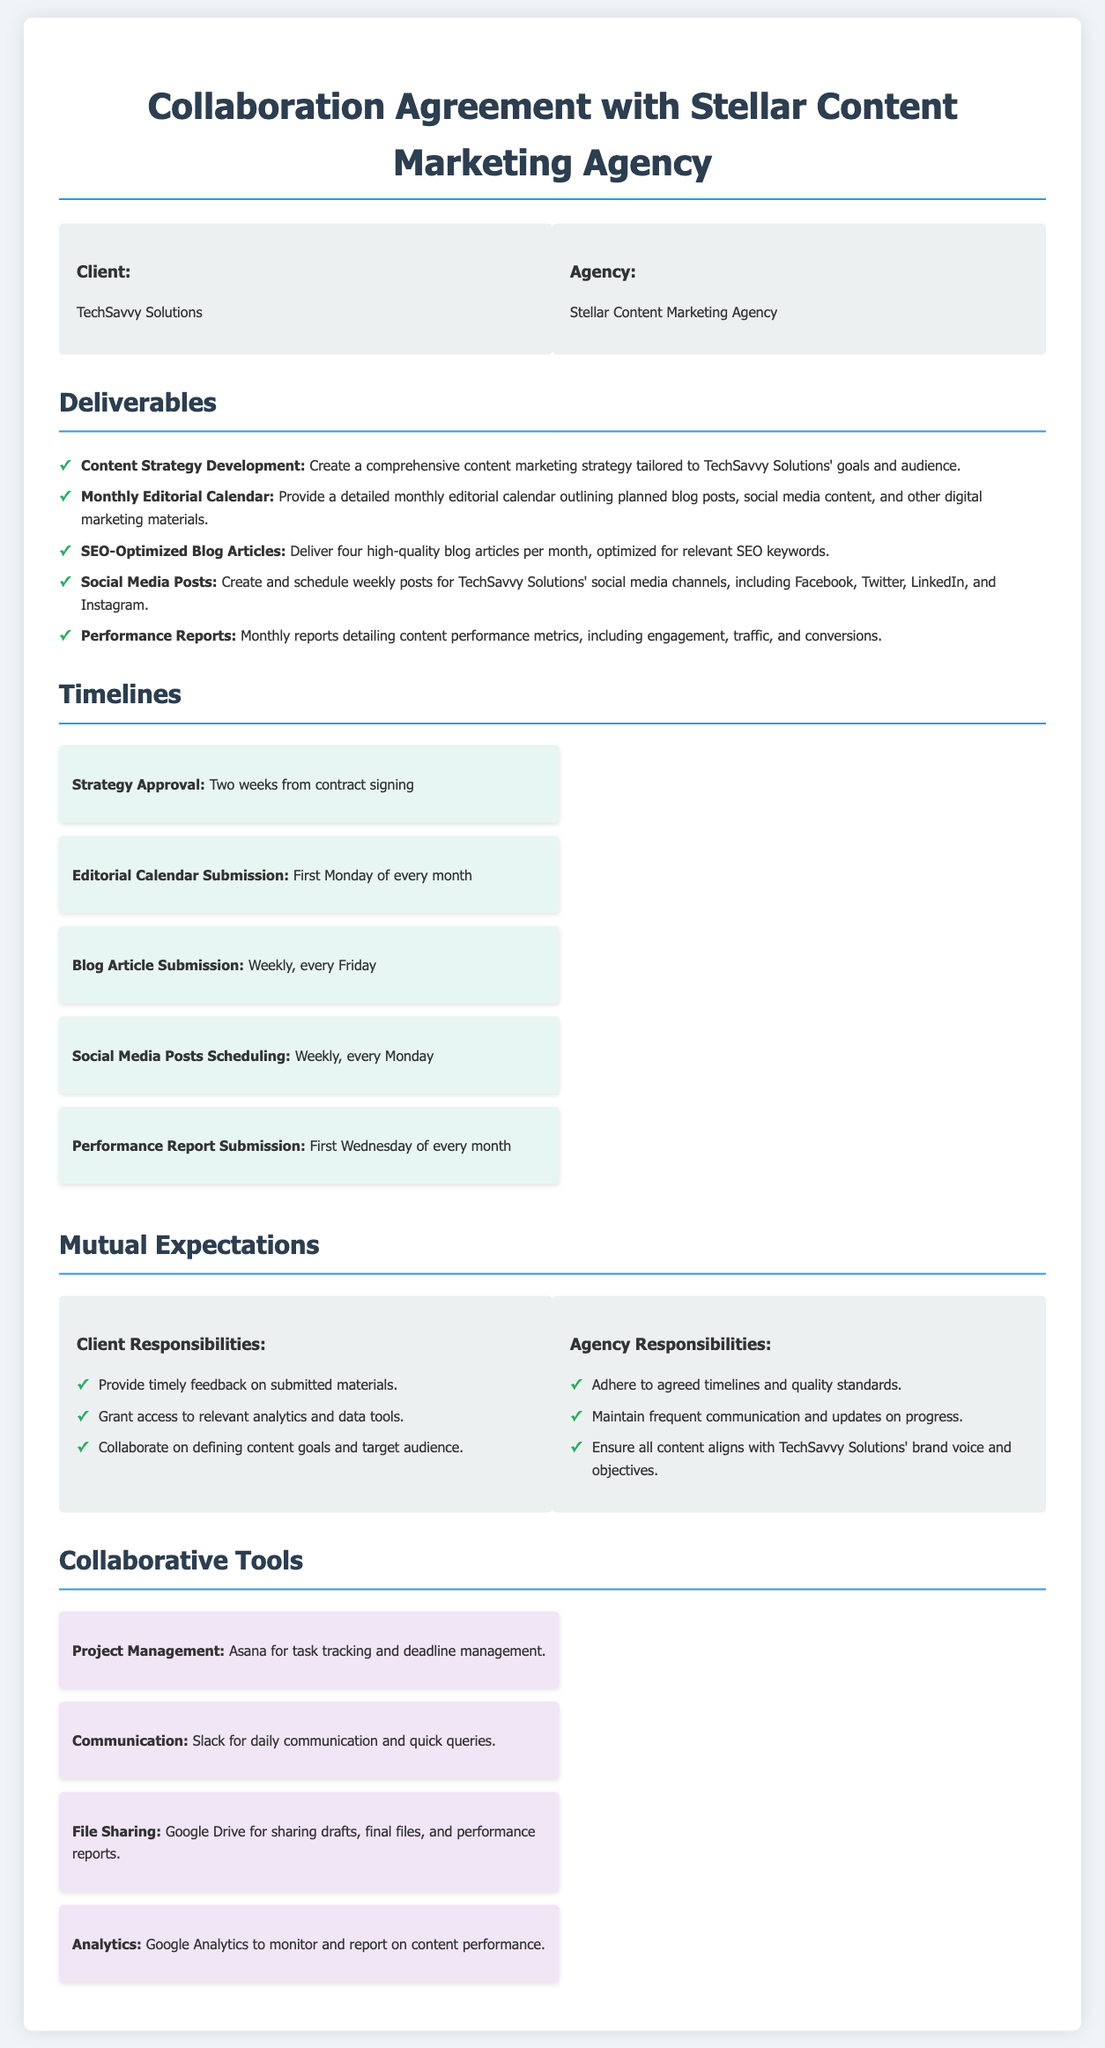What is the name of the client? The client's name is provided in the parties section of the document.
Answer: TechSavvy Solutions How many blog articles are to be delivered monthly? This information is found in the deliverables section detailing the quantity of articles.
Answer: Four When is the first editorial calendar submission due? This is mentioned in the timeline section indicating the schedule for submissions.
Answer: First Monday of every month What tool is used for project management? The document specifies the tools used for collaboration, including project management.
Answer: Asana What is one of the agency's responsibilities? This can be found in the mutual expectations section outlining the agency's commitments.
Answer: Adhere to agreed timelines and quality standards How frequently are performance reports submitted? The timeline section outlines how often performance reports are delivered.
Answer: Monthly What platform is used for communication? This detail is included in the collaborative tools section of the document.
Answer: Slack What is the timeline for strategy approval? The timeline section specifies the period for strategy approval after signing the contract.
Answer: Two weeks from contract signing Which analytics tool is mentioned? The collaborative tools section includes specific tools for various tasks, including analytics.
Answer: Google Analytics 